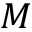Convert formula to latex. <formula><loc_0><loc_0><loc_500><loc_500>M</formula> 